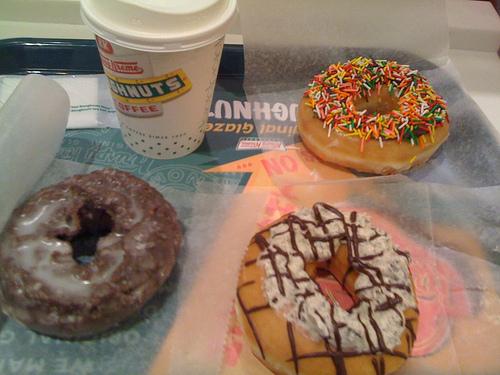How many consumable items are pictured?
Write a very short answer. 4. Is this a healthy breakfast?
Give a very brief answer. No. Are there any sprinkles?
Quick response, please. Yes. 